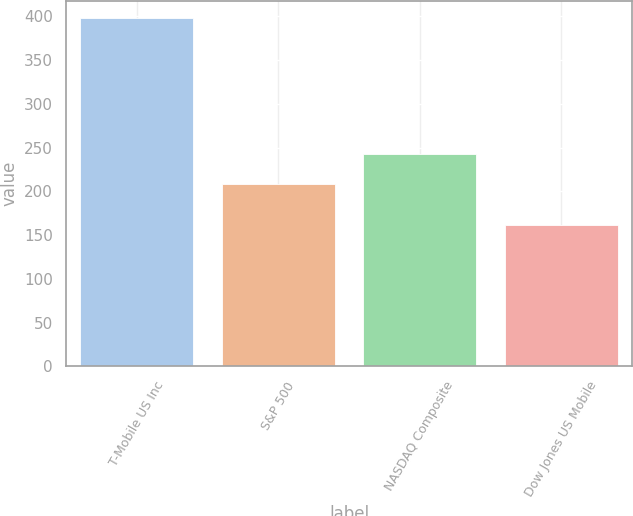Convert chart. <chart><loc_0><loc_0><loc_500><loc_500><bar_chart><fcel>T-Mobile US Inc<fcel>S&P 500<fcel>NASDAQ Composite<fcel>Dow Jones US Mobile<nl><fcel>397.77<fcel>208.14<fcel>242.29<fcel>161.29<nl></chart> 